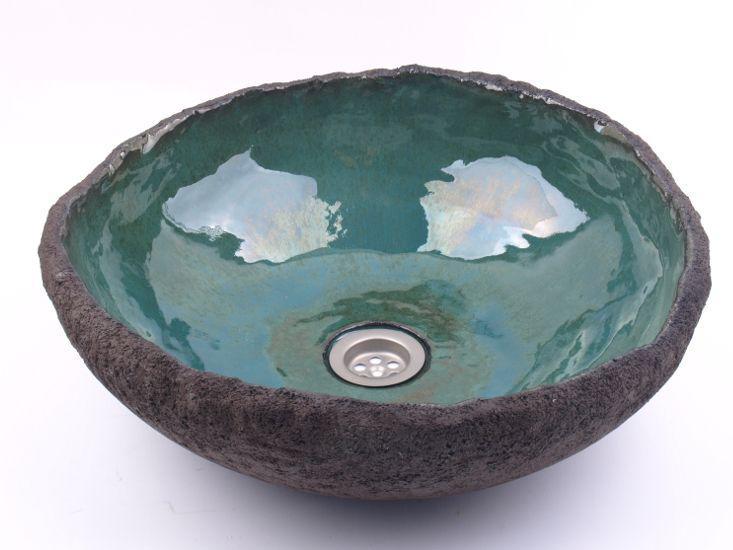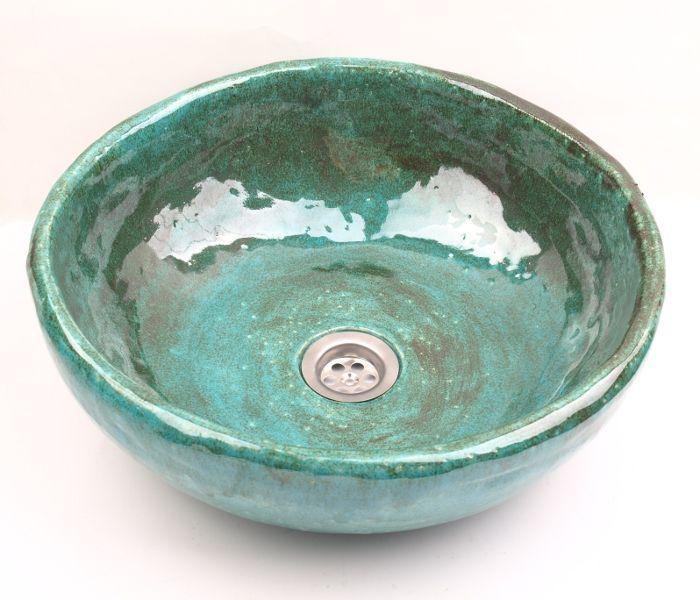The first image is the image on the left, the second image is the image on the right. For the images shown, is this caption "A gold-colored spout extends over a vessel sink with a decorated exterior set atop a tile counter in the left image, and the right image shows a sink with a hole inside." true? Answer yes or no. No. The first image is the image on the left, the second image is the image on the right. Considering the images on both sides, is "There is a sink bowl underneath a faucet." valid? Answer yes or no. No. 